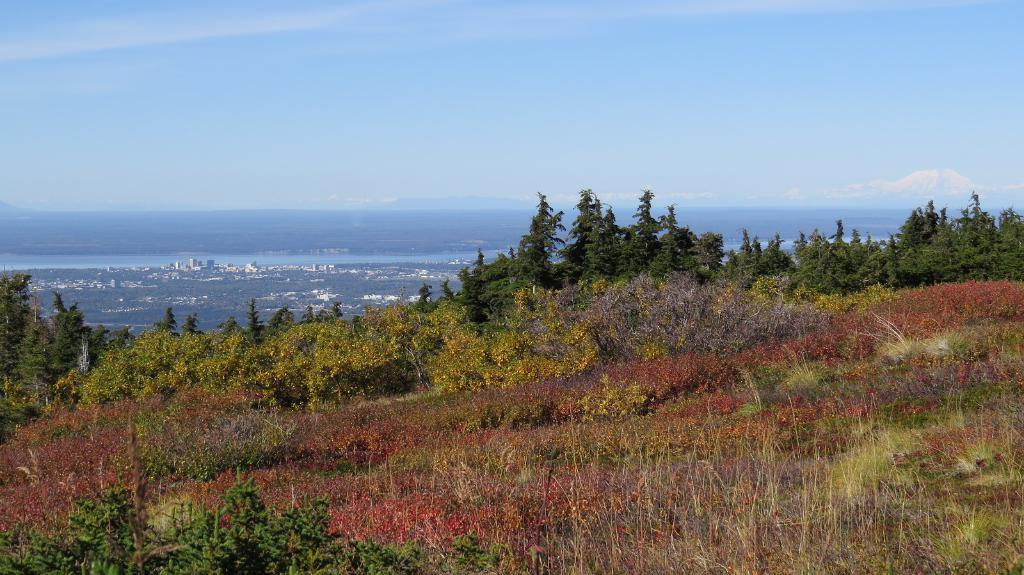What type of vegetation is present on the ground in the image? There are trees on the ground in the image. What type of structures can be seen in the background of the image? There are buildings in the background of the image. What natural element is visible in the background of the image? Water is visible in the background of the image. What is visible above the buildings and water in the image? The sky is visible in the background of the image. What can be observed in the sky in the image? Clouds are present in the sky. What type of amusement can be seen in the flesh in the image? There is no amusement or flesh present in the image; it features trees, buildings, water, sky, and clouds. 